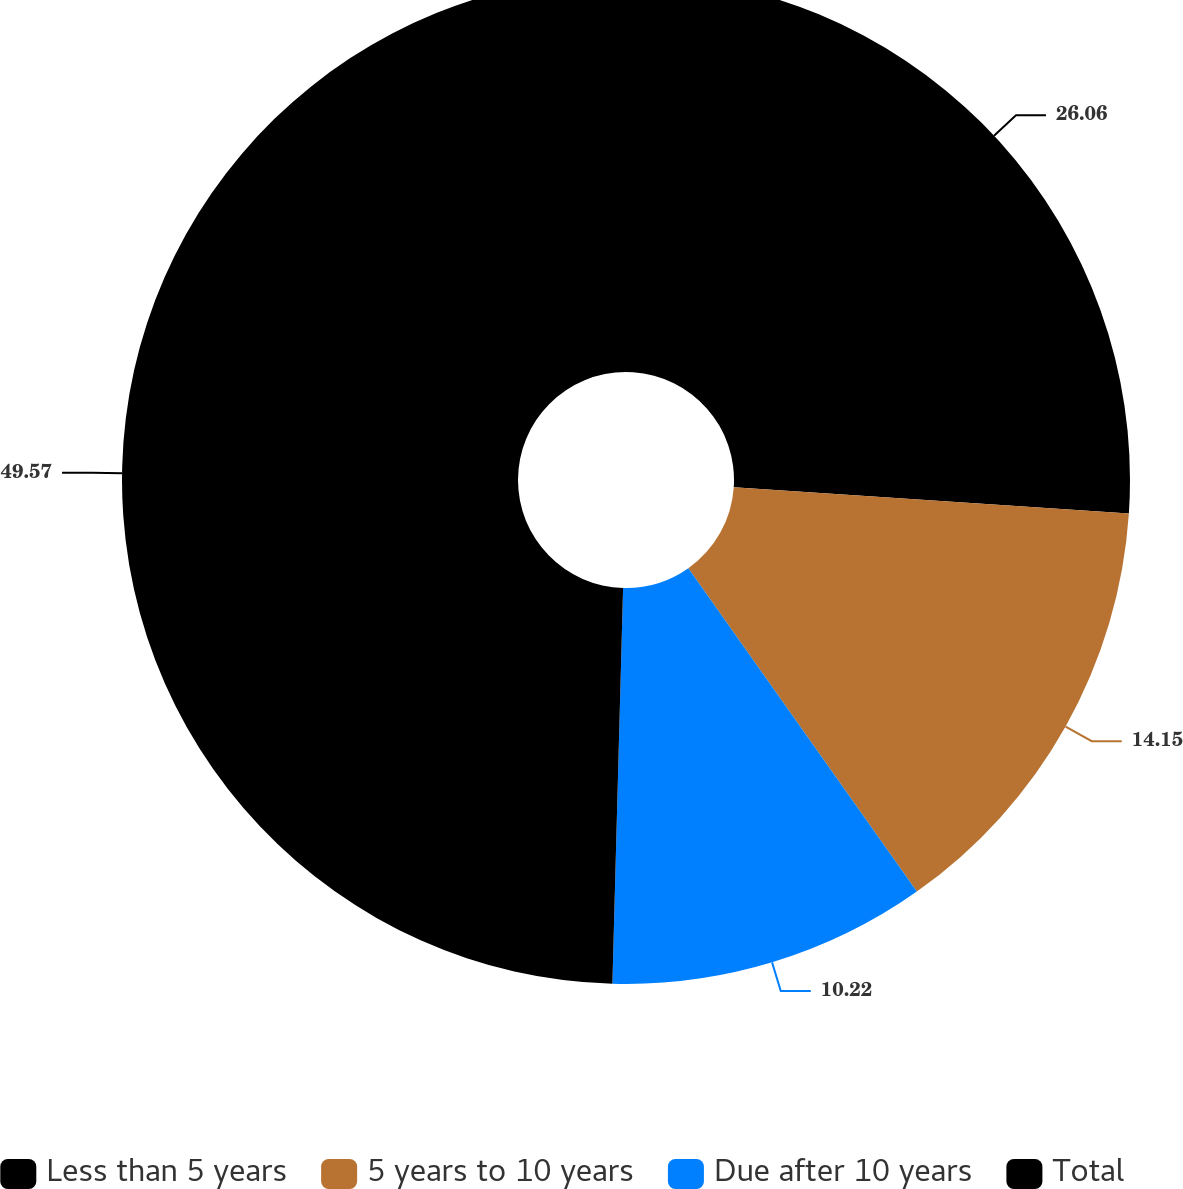<chart> <loc_0><loc_0><loc_500><loc_500><pie_chart><fcel>Less than 5 years<fcel>5 years to 10 years<fcel>Due after 10 years<fcel>Total<nl><fcel>26.06%<fcel>14.15%<fcel>10.22%<fcel>49.57%<nl></chart> 